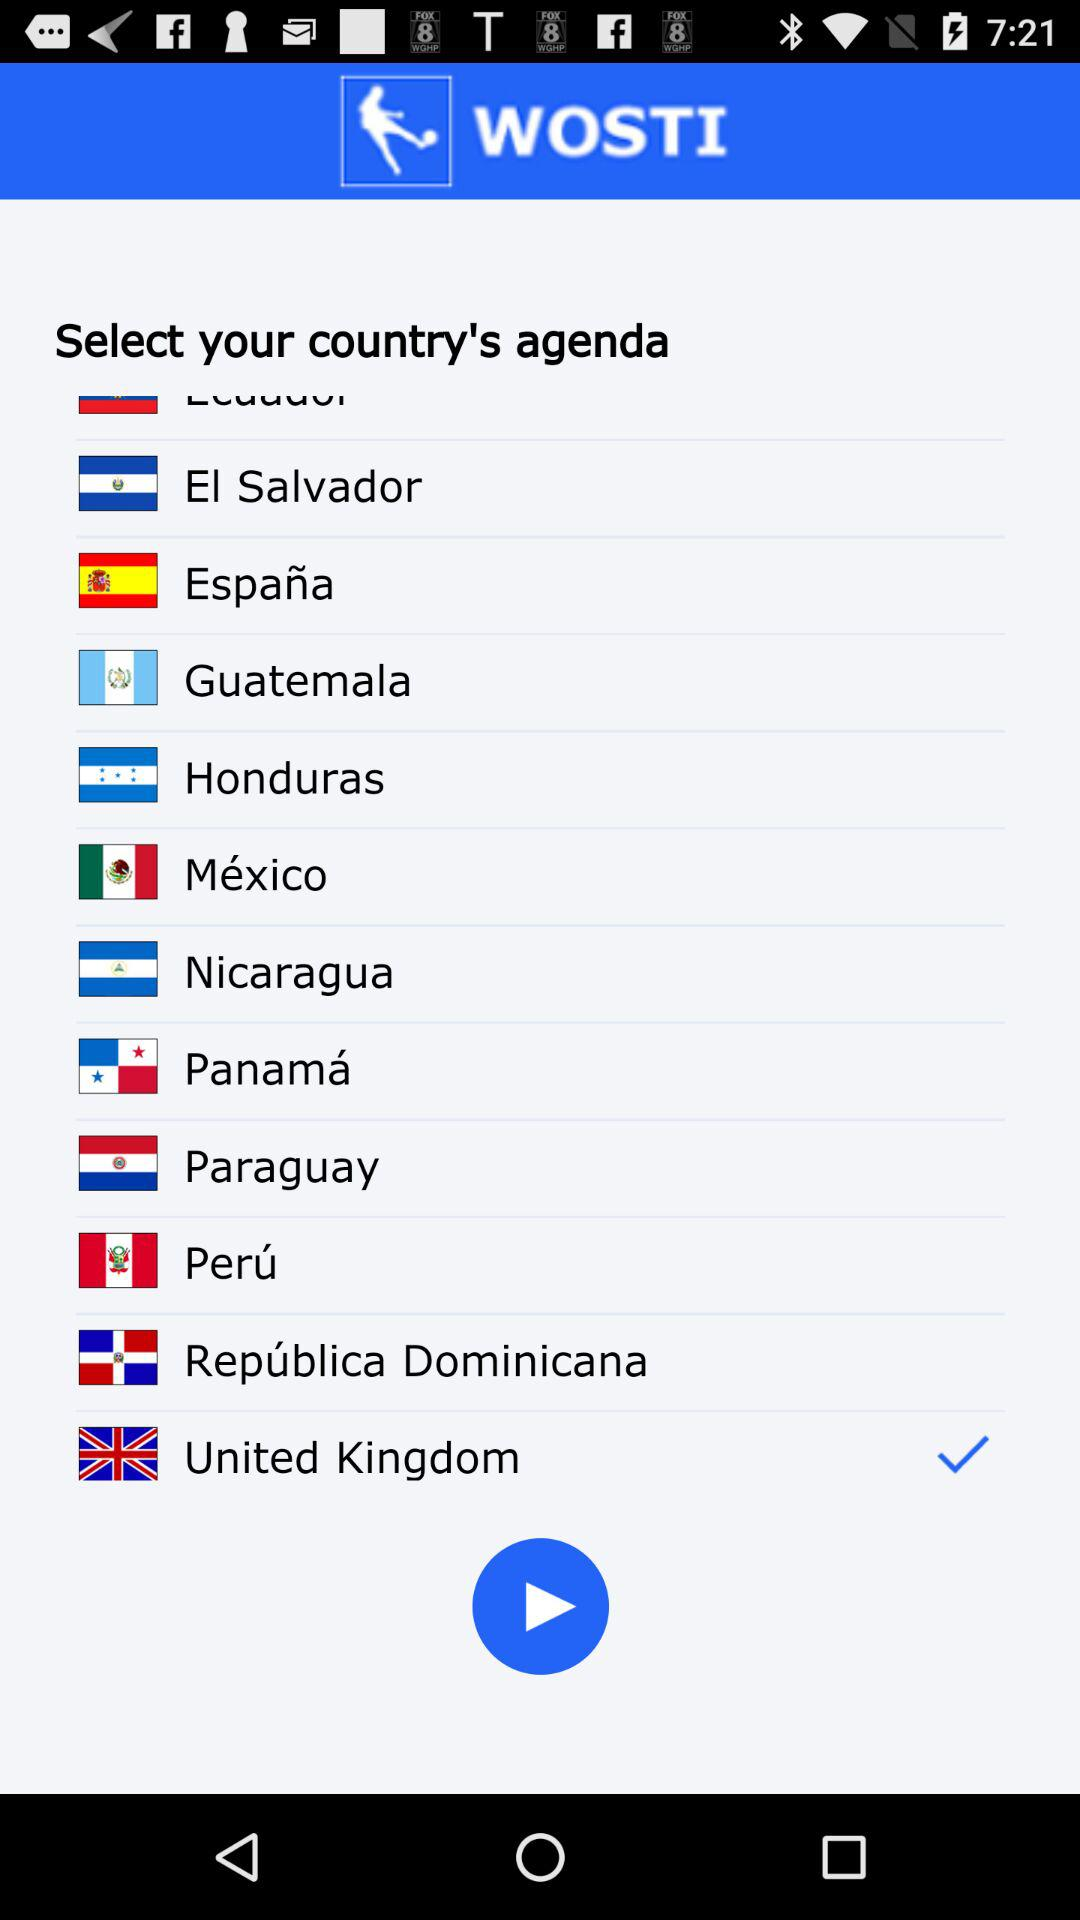Which is the selected country? The selected country is the United Kingdom. 